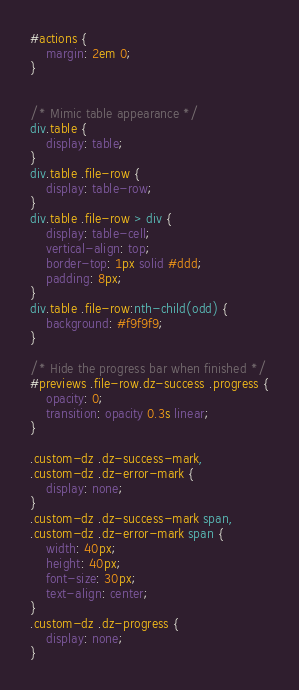Convert code to text. <code><loc_0><loc_0><loc_500><loc_500><_CSS_>
#actions {
    margin: 2em 0;
}


/* Mimic table appearance */
div.table {
    display: table;
}
div.table .file-row {
    display: table-row;
}
div.table .file-row > div {
    display: table-cell;
    vertical-align: top;
    border-top: 1px solid #ddd;
    padding: 8px;
}
div.table .file-row:nth-child(odd) {
    background: #f9f9f9;
}

/* Hide the progress bar when finished */
#previews .file-row.dz-success .progress {
    opacity: 0;
    transition: opacity 0.3s linear;
}

.custom-dz .dz-success-mark,
.custom-dz .dz-error-mark {
    display: none;
}
.custom-dz .dz-success-mark span,
.custom-dz .dz-error-mark span {
    width: 40px;
    height: 40px;
    font-size: 30px;
    text-align: center;
}
.custom-dz .dz-progress {
    display: none;
}</code> 